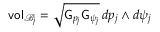<formula> <loc_0><loc_0><loc_500><loc_500>v o l _ { \mathcal { B } _ { j } } = \sqrt { G _ { p _ { j } } G _ { \psi _ { j } } } \, d p _ { j } \wedge d \psi _ { j }</formula> 